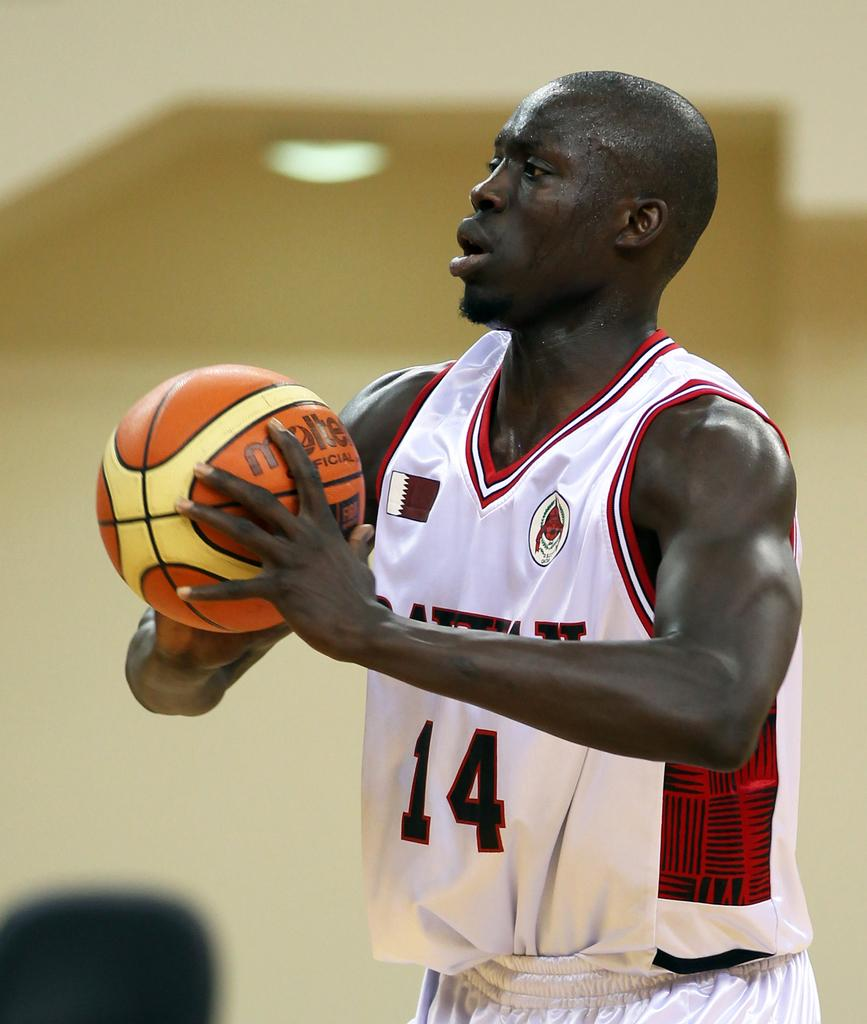What is the main subject of the image? There is a person in the image. What is the person doing in the image? The person is standing and catching a ball. What type of stone can be seen in the image? There is no stone present in the image; it features a person standing and catching a ball. What kind of fowl is visible in the image? There is no fowl present in the image; it features a person standing and catching a ball. 